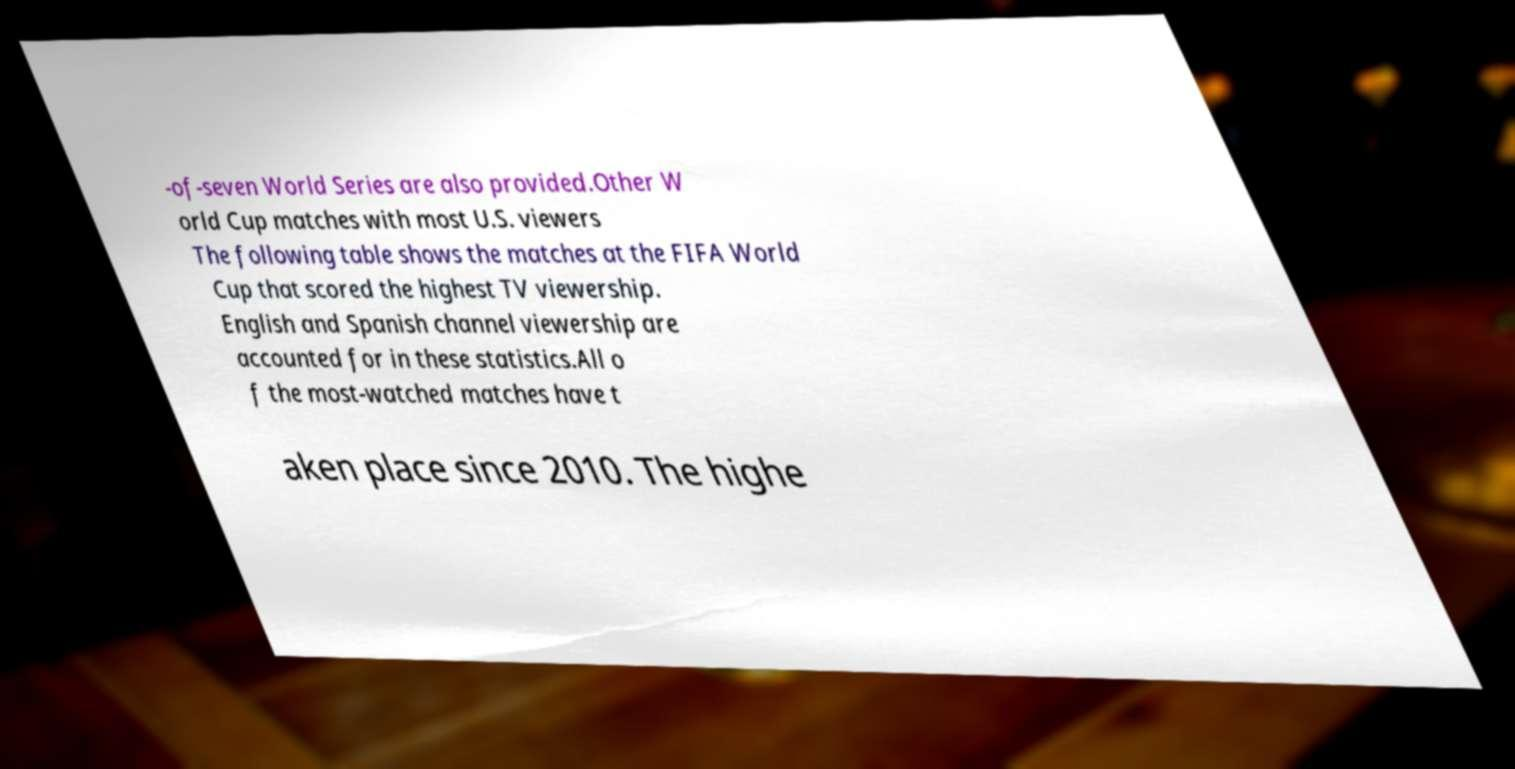What messages or text are displayed in this image? I need them in a readable, typed format. -of-seven World Series are also provided.Other W orld Cup matches with most U.S. viewers The following table shows the matches at the FIFA World Cup that scored the highest TV viewership. English and Spanish channel viewership are accounted for in these statistics.All o f the most-watched matches have t aken place since 2010. The highe 